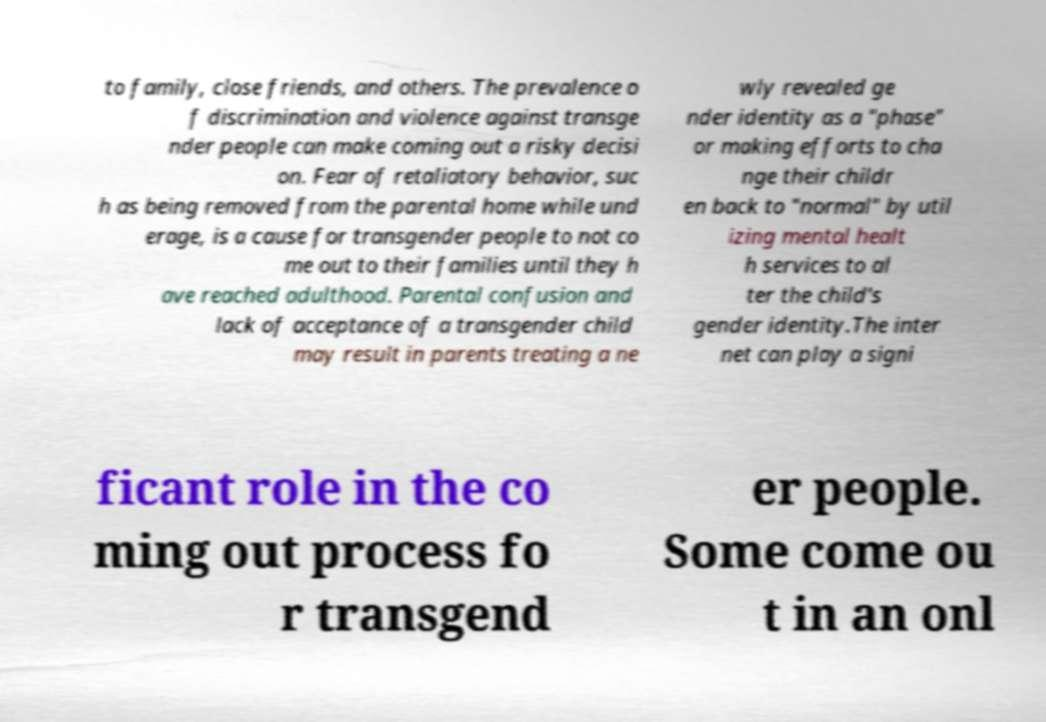Can you accurately transcribe the text from the provided image for me? to family, close friends, and others. The prevalence o f discrimination and violence against transge nder people can make coming out a risky decisi on. Fear of retaliatory behavior, suc h as being removed from the parental home while und erage, is a cause for transgender people to not co me out to their families until they h ave reached adulthood. Parental confusion and lack of acceptance of a transgender child may result in parents treating a ne wly revealed ge nder identity as a "phase" or making efforts to cha nge their childr en back to "normal" by util izing mental healt h services to al ter the child's gender identity.The inter net can play a signi ficant role in the co ming out process fo r transgend er people. Some come ou t in an onl 